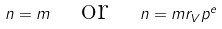<formula> <loc_0><loc_0><loc_500><loc_500>n = m \quad \text {or} \quad n = m r _ { V } p ^ { e }</formula> 